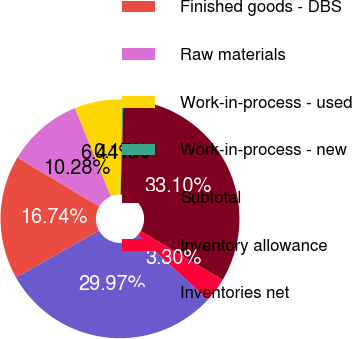Convert chart. <chart><loc_0><loc_0><loc_500><loc_500><pie_chart><fcel>Finished goods - DBS<fcel>Raw materials<fcel>Work-in-process - used<fcel>Work-in-process - new<fcel>Subtotal<fcel>Inventory allowance<fcel>Inventories net<nl><fcel>16.74%<fcel>10.28%<fcel>6.44%<fcel>0.17%<fcel>33.1%<fcel>3.3%<fcel>29.97%<nl></chart> 